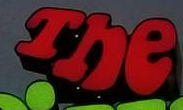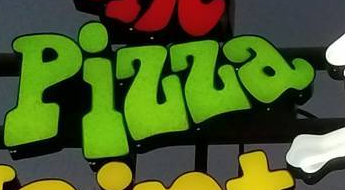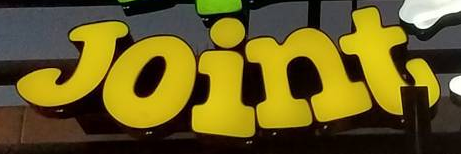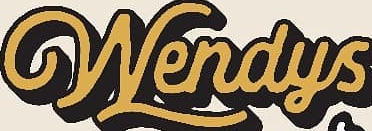Transcribe the words shown in these images in order, separated by a semicolon. The; Pizza; Joint; Wendys 